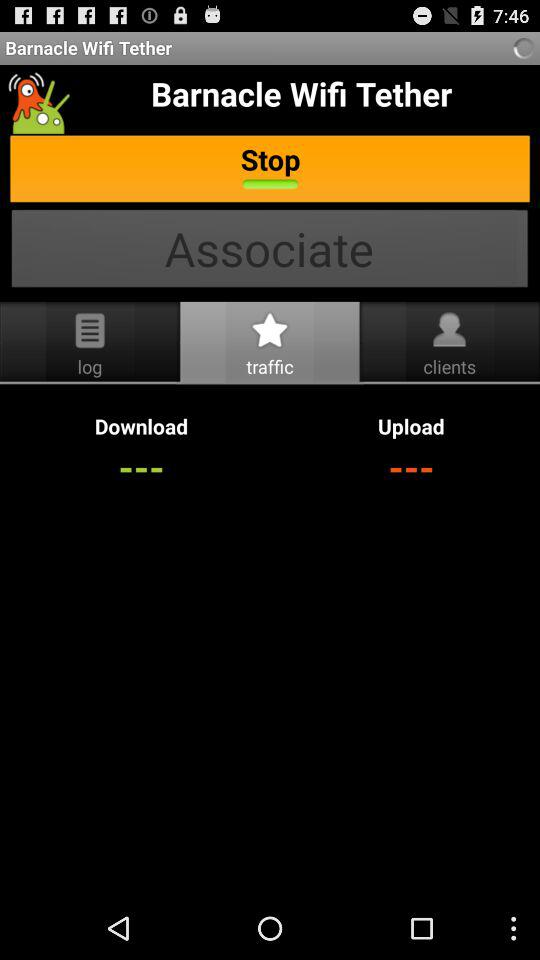What tab is currently selected? The selected tab is "traffic". 